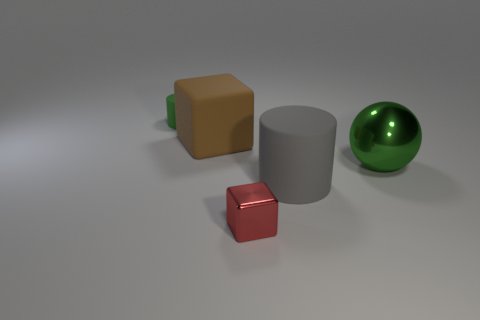Add 3 tiny purple metal spheres. How many objects exist? 8 Subtract all balls. How many objects are left? 4 Subtract 0 green blocks. How many objects are left? 5 Subtract all tiny red spheres. Subtract all big green shiny spheres. How many objects are left? 4 Add 2 small green cylinders. How many small green cylinders are left? 3 Add 2 tiny red objects. How many tiny red objects exist? 3 